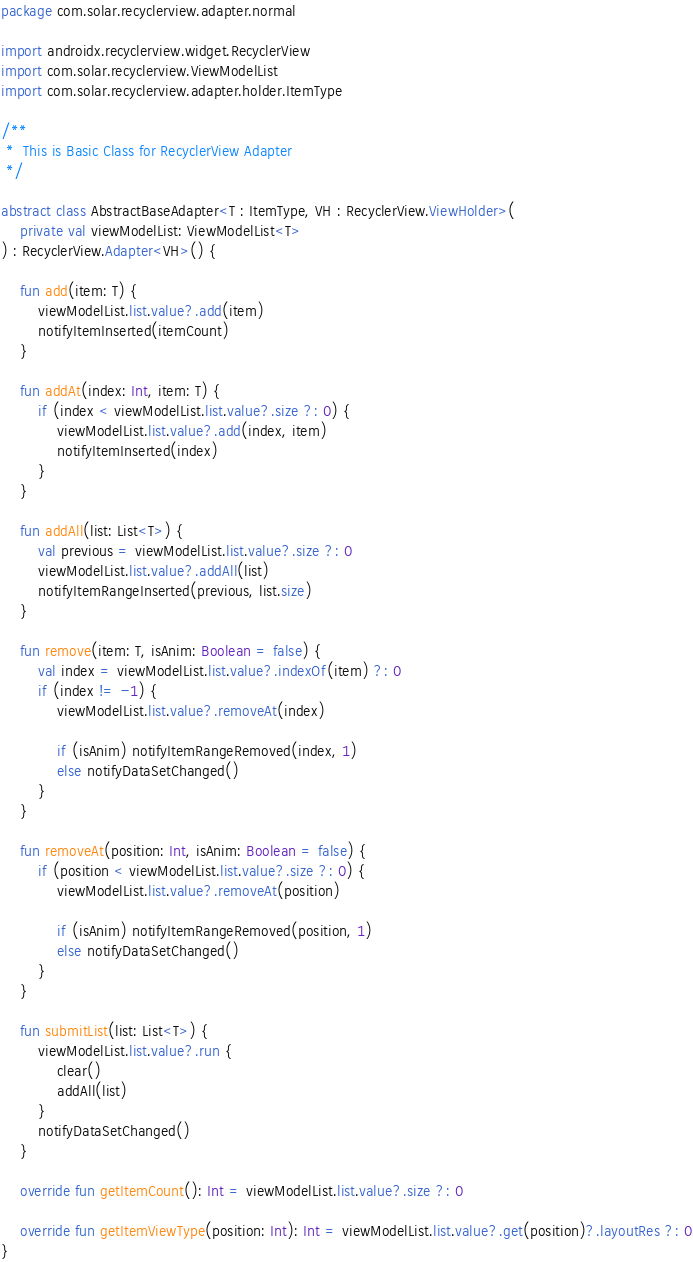Convert code to text. <code><loc_0><loc_0><loc_500><loc_500><_Kotlin_>package com.solar.recyclerview.adapter.normal

import androidx.recyclerview.widget.RecyclerView
import com.solar.recyclerview.ViewModelList
import com.solar.recyclerview.adapter.holder.ItemType

/**
 *  This is Basic Class for RecyclerView Adapter
 */

abstract class AbstractBaseAdapter<T : ItemType, VH : RecyclerView.ViewHolder>(
    private val viewModelList: ViewModelList<T>
) : RecyclerView.Adapter<VH>() {

    fun add(item: T) {
        viewModelList.list.value?.add(item)
        notifyItemInserted(itemCount)
    }

    fun addAt(index: Int, item: T) {
        if (index < viewModelList.list.value?.size ?: 0) {
            viewModelList.list.value?.add(index, item)
            notifyItemInserted(index)
        }
    }

    fun addAll(list: List<T>) {
        val previous = viewModelList.list.value?.size ?: 0
        viewModelList.list.value?.addAll(list)
        notifyItemRangeInserted(previous, list.size)
    }

    fun remove(item: T, isAnim: Boolean = false) {
        val index = viewModelList.list.value?.indexOf(item) ?: 0
        if (index != -1) {
            viewModelList.list.value?.removeAt(index)

            if (isAnim) notifyItemRangeRemoved(index, 1)
            else notifyDataSetChanged()
        }
    }

    fun removeAt(position: Int, isAnim: Boolean = false) {
        if (position < viewModelList.list.value?.size ?: 0) {
            viewModelList.list.value?.removeAt(position)

            if (isAnim) notifyItemRangeRemoved(position, 1)
            else notifyDataSetChanged()
        }
    }

    fun submitList(list: List<T>) {
        viewModelList.list.value?.run {
            clear()
            addAll(list)
        }
        notifyDataSetChanged()
    }

    override fun getItemCount(): Int = viewModelList.list.value?.size ?: 0

    override fun getItemViewType(position: Int): Int = viewModelList.list.value?.get(position)?.layoutRes ?: 0
}</code> 